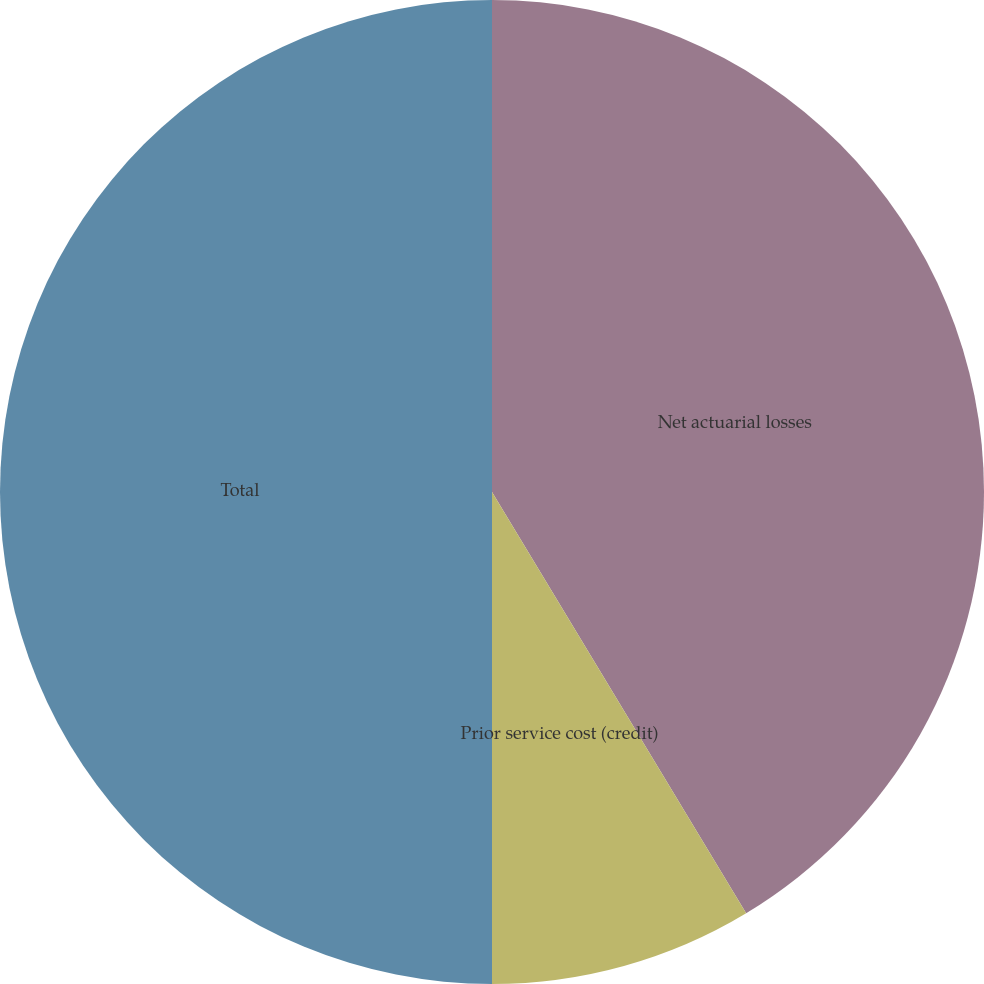Convert chart to OTSL. <chart><loc_0><loc_0><loc_500><loc_500><pie_chart><fcel>Net actuarial losses<fcel>Prior service cost (credit)<fcel>Total<nl><fcel>41.36%<fcel>8.64%<fcel>50.0%<nl></chart> 